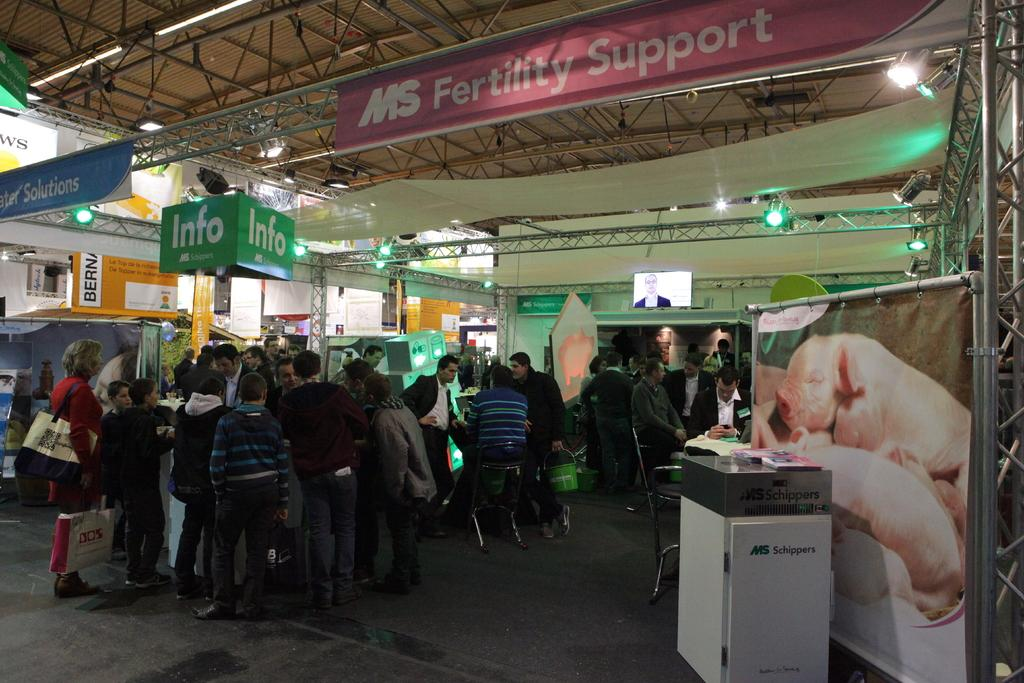<image>
Present a compact description of the photo's key features. A group of people at a conference on MS Fertility support. 